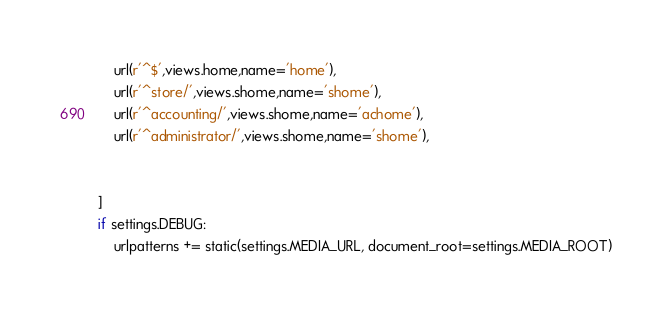<code> <loc_0><loc_0><loc_500><loc_500><_Python_>    url(r'^$',views.home,name='home'),
    url(r'^store/',views.shome,name='shome'),
    url(r'^accounting/',views.shome,name='achome'),
    url(r'^administrator/',views.shome,name='shome'),

   
]
if settings.DEBUG:
    urlpatterns += static(settings.MEDIA_URL, document_root=settings.MEDIA_ROOT)</code> 